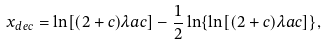Convert formula to latex. <formula><loc_0><loc_0><loc_500><loc_500>x _ { d e c } = \ln [ ( 2 + c ) \lambda a c ] - \frac { 1 } { 2 } \ln \{ \ln [ ( 2 + c ) \lambda a c ] \} ,</formula> 